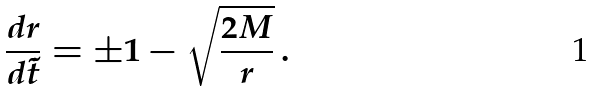<formula> <loc_0><loc_0><loc_500><loc_500>\frac { d r } { d \tilde { t } } = \pm 1 - \sqrt { \frac { 2 M } { r } } \, .</formula> 